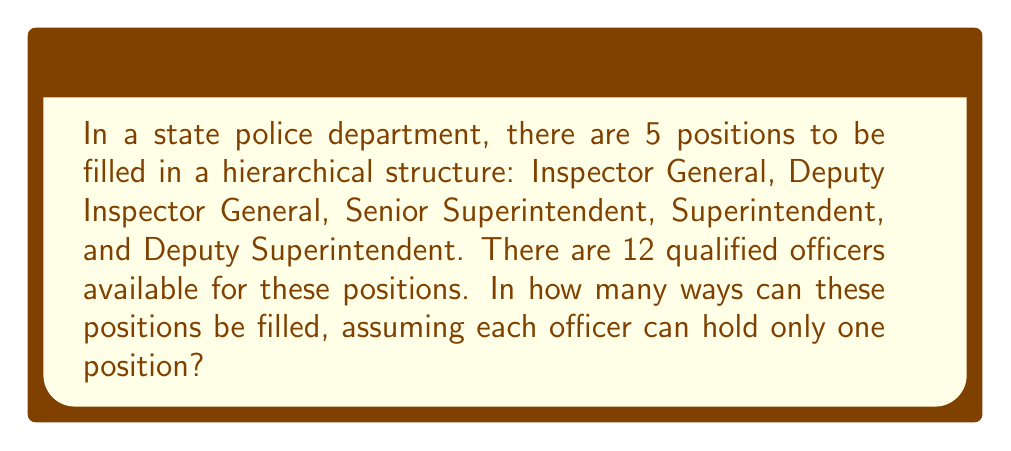Could you help me with this problem? To solve this problem, we need to use the concept of permutations. Since we are selecting 5 officers out of 12 for specific positions, and the order matters (as it's a hierarchical structure), we will use the permutation formula.

The formula for permutations is:

$$P(n,r) = \frac{n!}{(n-r)!}$$

Where:
$n$ = total number of items to choose from
$r$ = number of items being chosen

In this case:
$n = 12$ (total number of qualified officers)
$r = 5$ (number of positions to be filled)

Plugging these values into the formula:

$$P(12,5) = \frac{12!}{(12-5)!} = \frac{12!}{7!}$$

Now, let's calculate this step-by-step:

1) $12! = 12 \times 11 \times 10 \times 9 \times 8 \times 7!$

2) Simplify:
   $$\frac{12!}{7!} = \frac{12 \times 11 \times 10 \times 9 \times 8 \times 7!}{7!}$$

3) The $7!$ cancels out in the numerator and denominator:
   $$12 \times 11 \times 10 \times 9 \times 8 = 95,040$$

Therefore, there are 95,040 ways to organize the hierarchical structure within the police department.
Answer: 95,040 